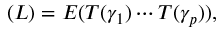<formula> <loc_0><loc_0><loc_500><loc_500>\L ( L ) = E ( T ( \gamma _ { 1 } ) \cdots T ( \gamma _ { p } ) ) ,</formula> 